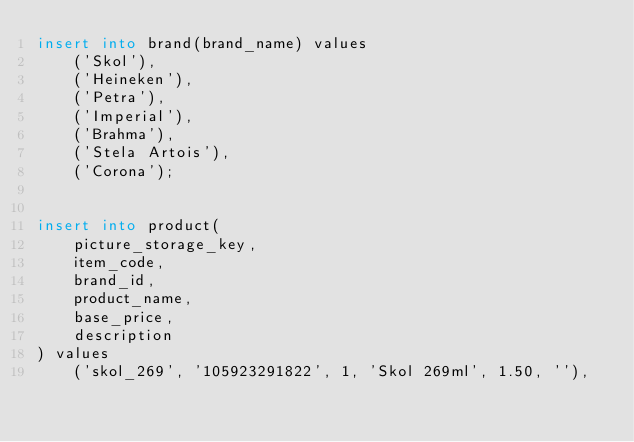<code> <loc_0><loc_0><loc_500><loc_500><_SQL_>insert into brand(brand_name) values
    ('Skol'),
    ('Heineken'),
    ('Petra'),
    ('Imperial'),
    ('Brahma'),
    ('Stela Artois'),
    ('Corona');


insert into product(
    picture_storage_key,
    item_code,
    brand_id,
    product_name,
    base_price,
    description
) values
    ('skol_269', '105923291822', 1, 'Skol 269ml', 1.50, ''),</code> 